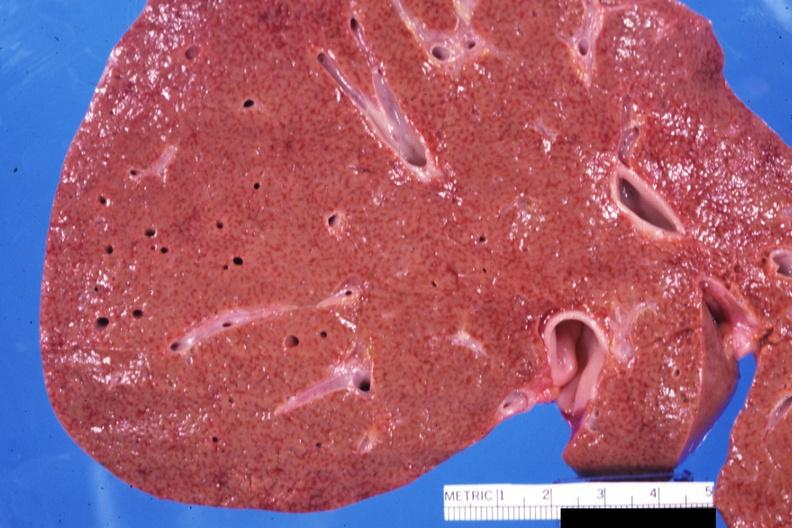s exact cause present?
Answer the question using a single word or phrase. No 